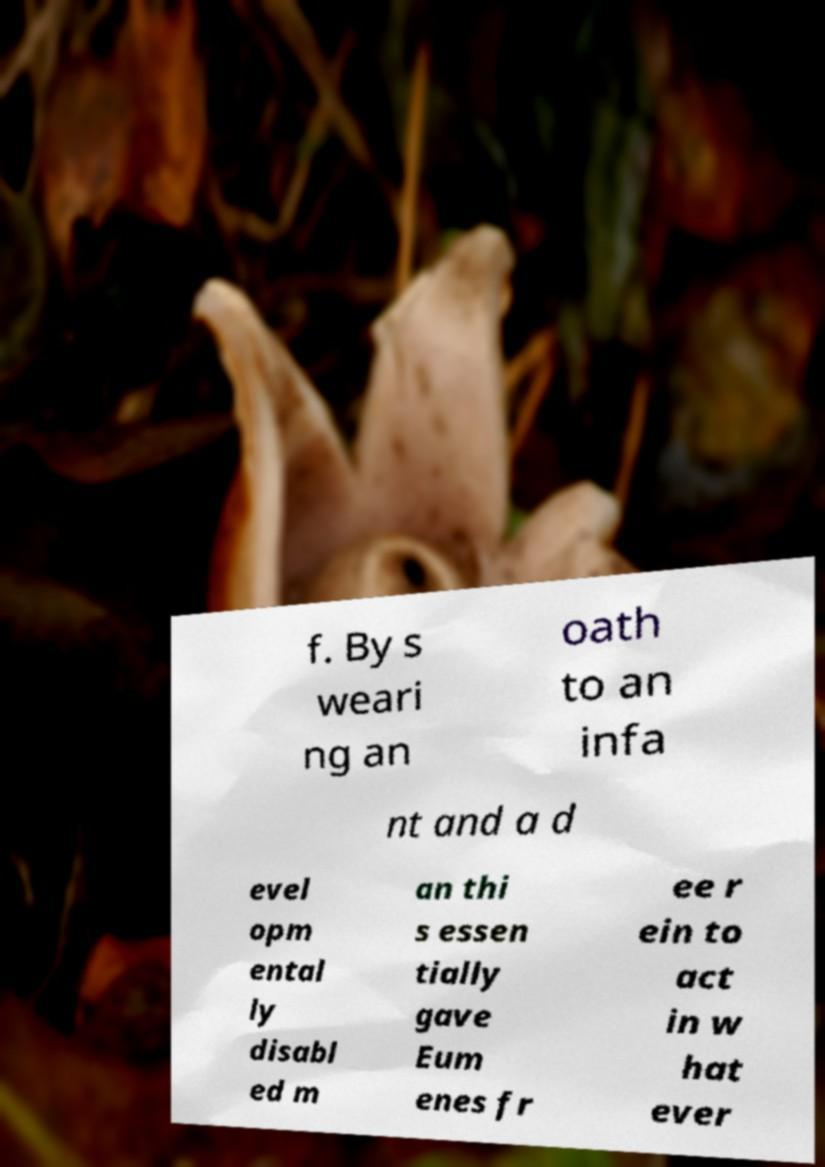What messages or text are displayed in this image? I need them in a readable, typed format. f. By s weari ng an oath to an infa nt and a d evel opm ental ly disabl ed m an thi s essen tially gave Eum enes fr ee r ein to act in w hat ever 